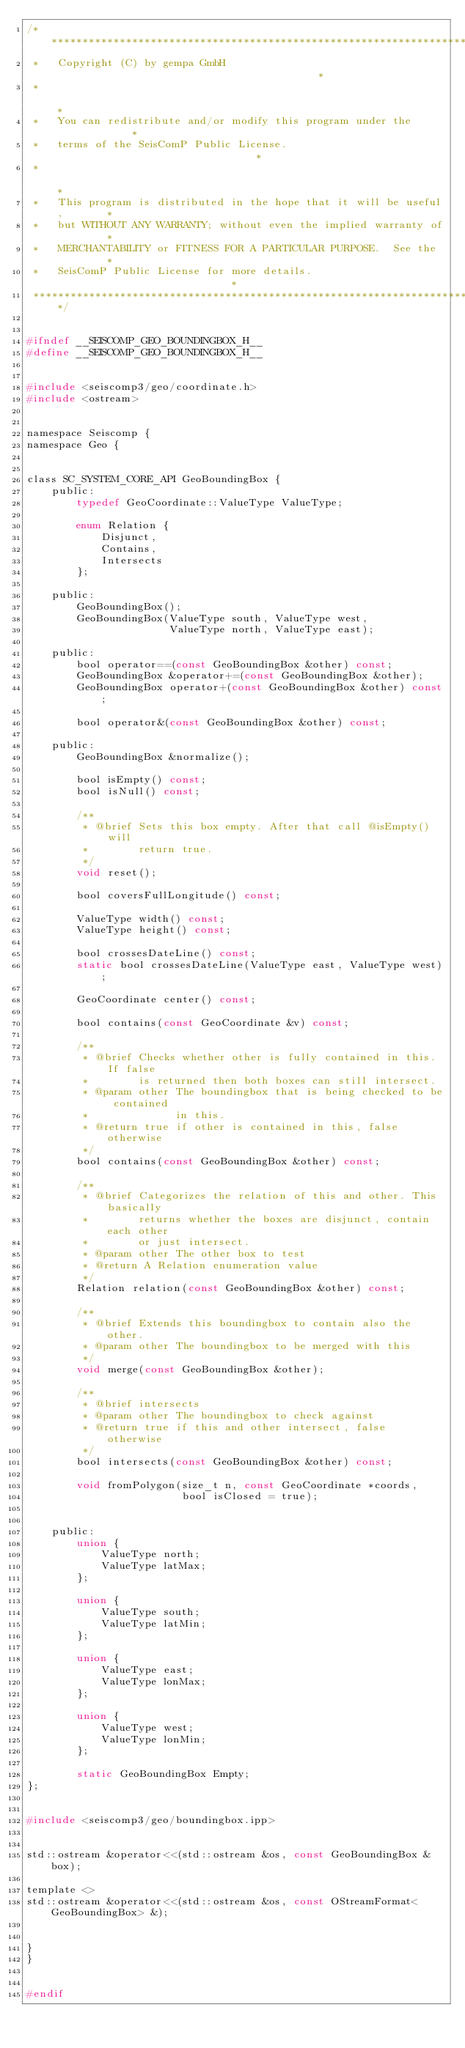Convert code to text. <code><loc_0><loc_0><loc_500><loc_500><_C_>/***************************************************************************
 *   Copyright (C) by gempa GmbH                                           *
 *                                                                         *
 *   You can redistribute and/or modify this program under the             *
 *   terms of the SeisComP Public License.                                 *
 *                                                                         *
 *   This program is distributed in the hope that it will be useful,       *
 *   but WITHOUT ANY WARRANTY; without even the implied warranty of        *
 *   MERCHANTABILITY or FITNESS FOR A PARTICULAR PURPOSE.  See the         *
 *   SeisComP Public License for more details.                             *
 ***************************************************************************/


#ifndef __SEISCOMP_GEO_BOUNDINGBOX_H__
#define __SEISCOMP_GEO_BOUNDINGBOX_H__


#include <seiscomp3/geo/coordinate.h>
#include <ostream>


namespace Seiscomp {
namespace Geo {


class SC_SYSTEM_CORE_API GeoBoundingBox {
	public:
		typedef GeoCoordinate::ValueType ValueType;

		enum Relation {
			Disjunct,
			Contains,
			Intersects
		};

	public:
		GeoBoundingBox();
		GeoBoundingBox(ValueType south, ValueType west,
		               ValueType north, ValueType east);

	public:
		bool operator==(const GeoBoundingBox &other) const;
		GeoBoundingBox &operator+=(const GeoBoundingBox &other);
		GeoBoundingBox operator+(const GeoBoundingBox &other) const;

		bool operator&(const GeoBoundingBox &other) const;

	public:
		GeoBoundingBox &normalize();

		bool isEmpty() const;
		bool isNull() const;

		/**
		 * @brief Sets this box empty. After that call @isEmpty() will
		 *        return true.
		 */
		void reset();

		bool coversFullLongitude() const;

		ValueType width() const;
		ValueType height() const;

		bool crossesDateLine() const;
		static bool crossesDateLine(ValueType east, ValueType west);

		GeoCoordinate center() const;

		bool contains(const GeoCoordinate &v) const;

		/**
		 * @brief Checks whether other is fully contained in this. If false
		 *        is returned then both boxes can still intersect.
		 * @param other The boundingbox that is being checked to be contained
		 *              in this.
		 * @return true if other is contained in this, false otherwise
		 */
		bool contains(const GeoBoundingBox &other) const;

		/**
		 * @brief Categorizes the relation of this and other. This basically
		 *        returns whether the boxes are disjunct, contain each other
		 *        or just intersect.
		 * @param other The other box to test
		 * @return A Relation enumeration value
		 */
		Relation relation(const GeoBoundingBox &other) const;

		/**
		 * @brief Extends this boundingbox to contain also the other.
		 * @param other The boundingbox to be merged with this
		 */
		void merge(const GeoBoundingBox &other);

		/**
		 * @brief intersects
		 * @param other The boundingbox to check against
		 * @return true if this and other intersect, false otherwise
		 */
		bool intersects(const GeoBoundingBox &other) const;

		void fromPolygon(size_t n, const GeoCoordinate *coords,
		                 bool isClosed = true);


	public:
		union {
			ValueType north;
			ValueType latMax;
		};

		union {
			ValueType south;
			ValueType latMin;
		};

		union {
			ValueType east;
			ValueType lonMax;
		};

		union {
			ValueType west;
			ValueType lonMin;
		};

		static GeoBoundingBox Empty;
};


#include <seiscomp3/geo/boundingbox.ipp>


std::ostream &operator<<(std::ostream &os, const GeoBoundingBox &box);

template <>
std::ostream &operator<<(std::ostream &os, const OStreamFormat<GeoBoundingBox> &);


}
}


#endif
</code> 